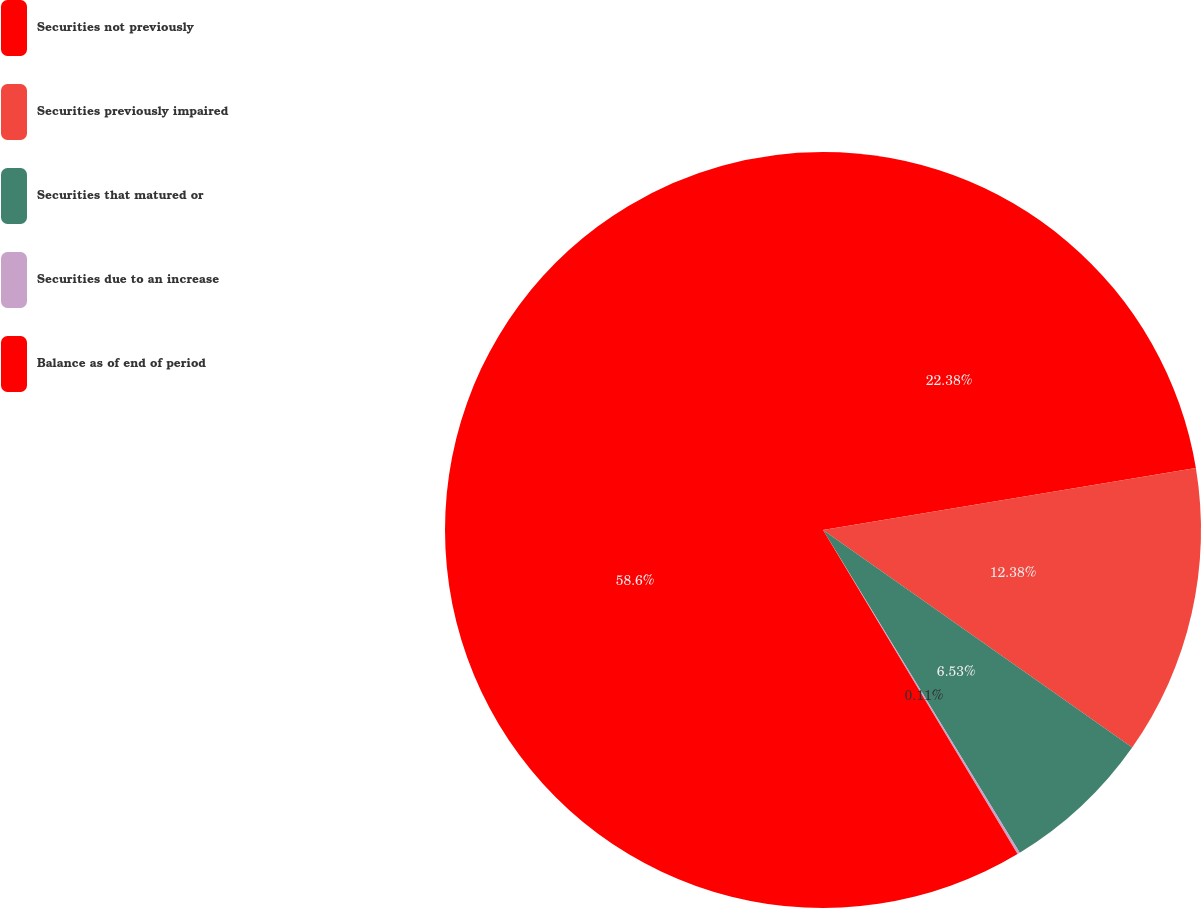Convert chart. <chart><loc_0><loc_0><loc_500><loc_500><pie_chart><fcel>Securities not previously<fcel>Securities previously impaired<fcel>Securities that matured or<fcel>Securities due to an increase<fcel>Balance as of end of period<nl><fcel>22.38%<fcel>12.38%<fcel>6.53%<fcel>0.11%<fcel>58.61%<nl></chart> 